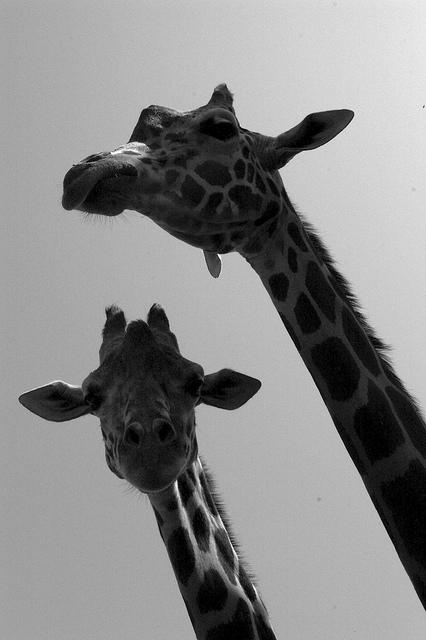Why is the giraffe head between the fence?
Concise answer only. It isn't. What are the animals shown?
Concise answer only. Giraffes. Are the giraffes eating?
Short answer required. No. What color is the photo?
Short answer required. Black and white. 